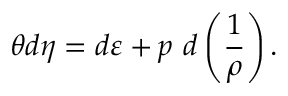<formula> <loc_0><loc_0><loc_500><loc_500>\theta d \eta = d \varepsilon + p \ d \left ( \frac { 1 } { \rho } \right ) .</formula> 